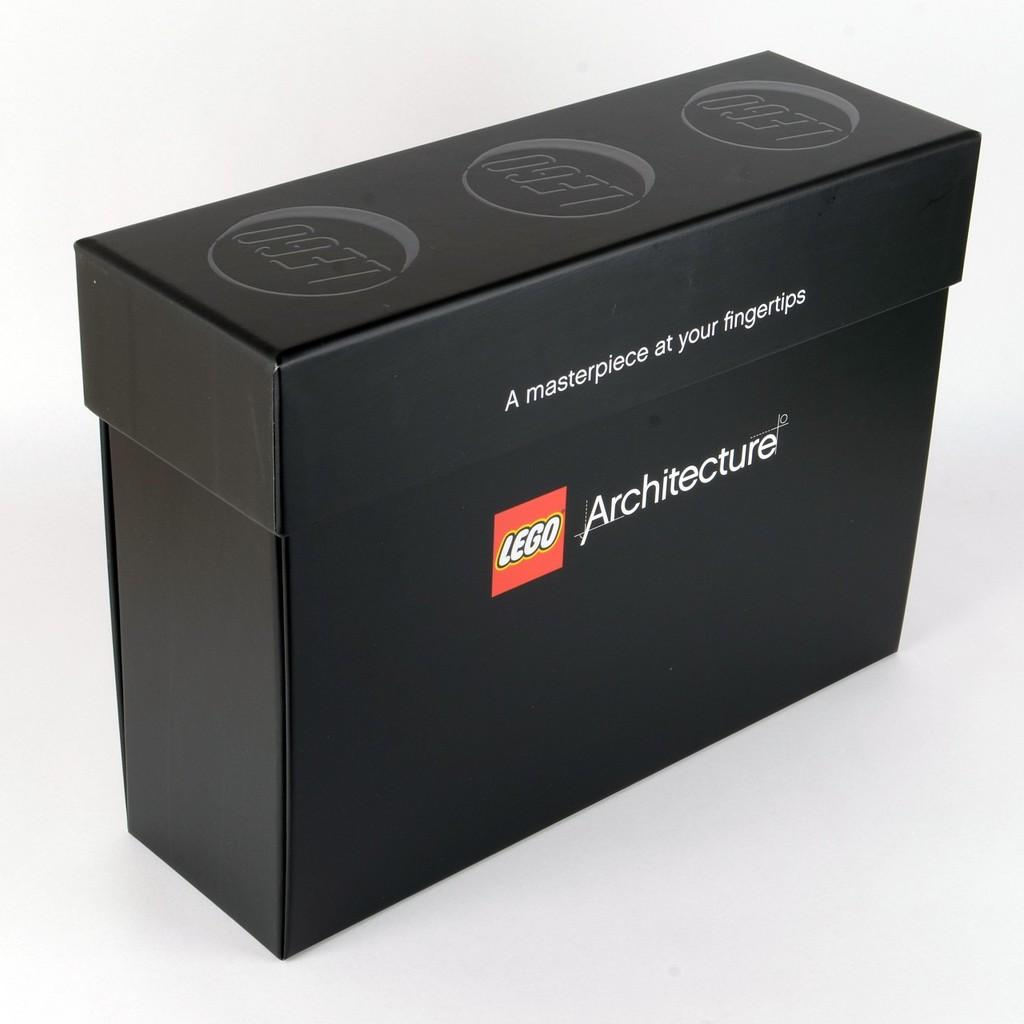<image>
Share a concise interpretation of the image provided. A black Lego box saying A masterpiece at your fingertips. 